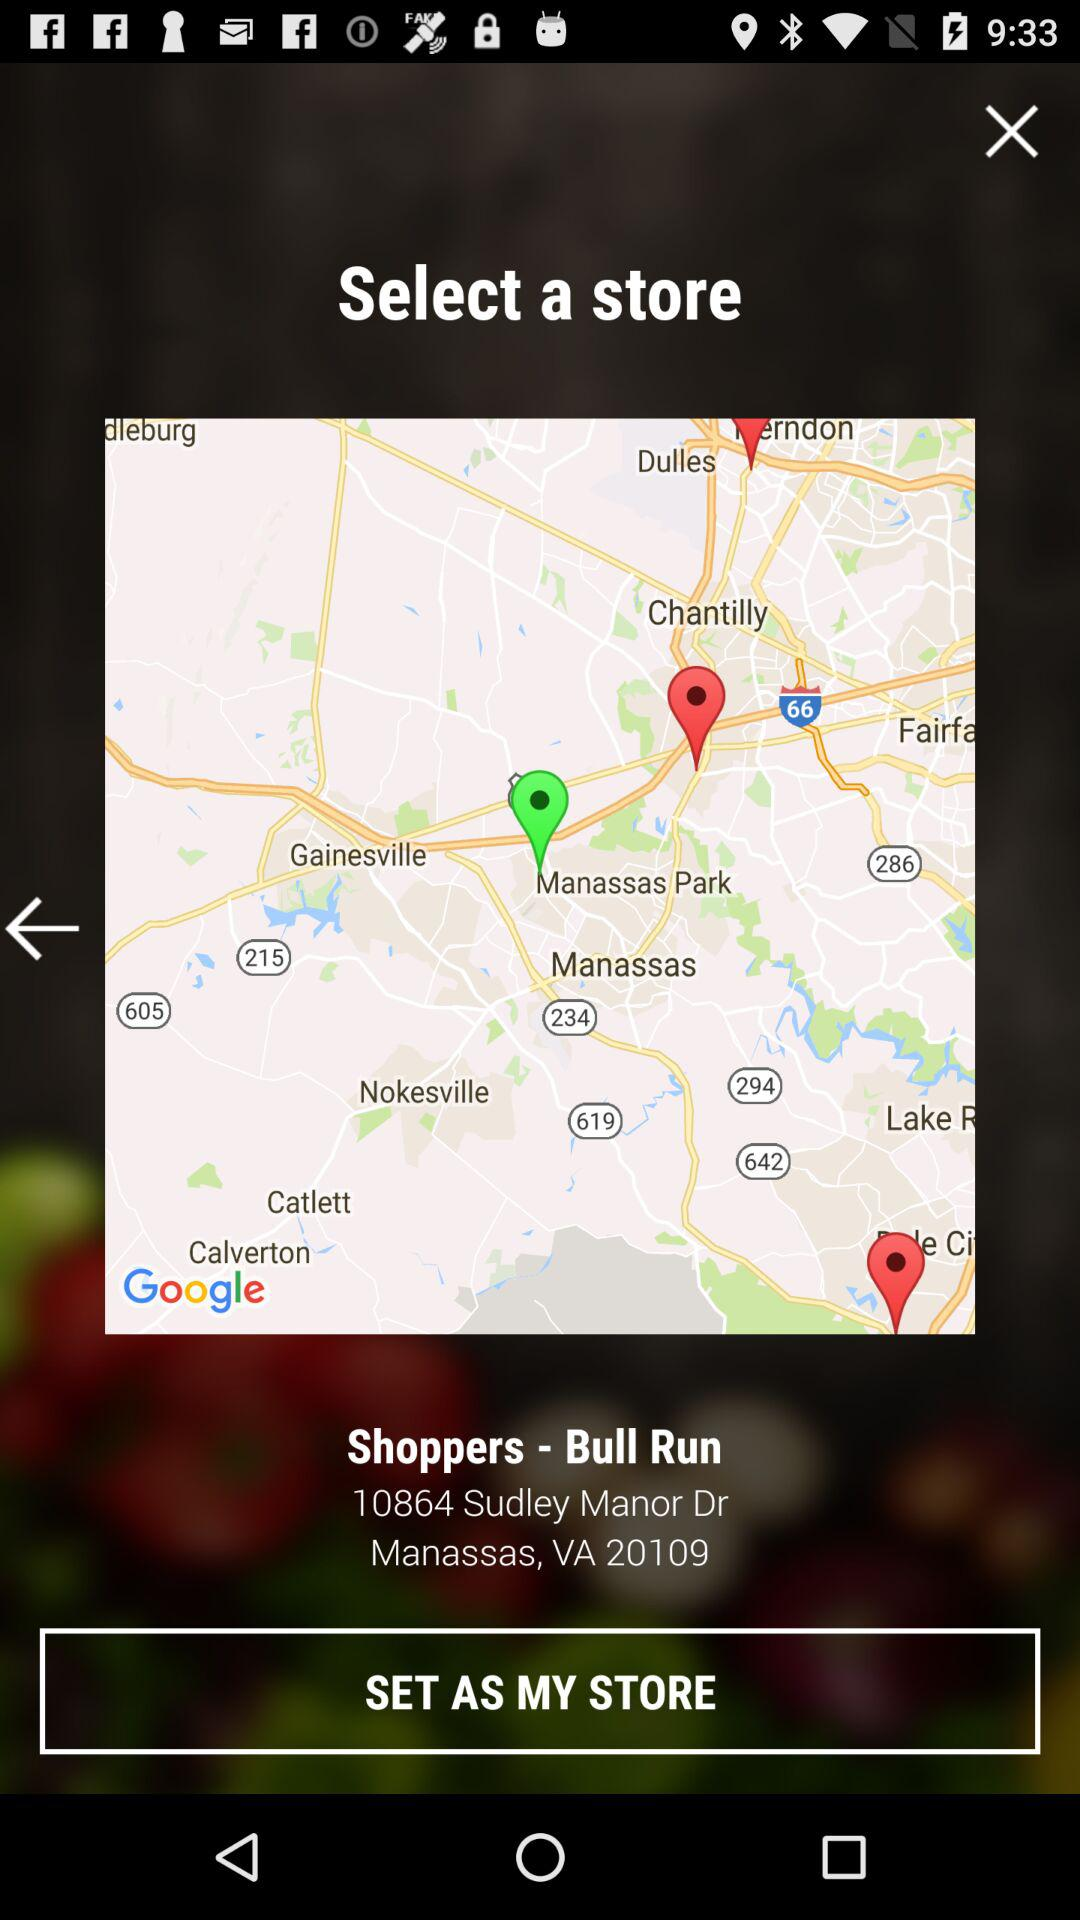What is the address of the store? The address is 10864 Sudley Manor Dr., Manassas, VA 20109. 